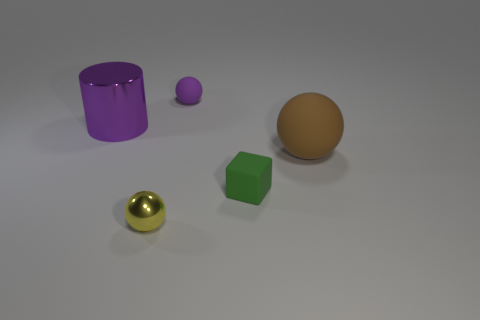Add 3 big red spheres. How many objects exist? 8 Subtract all balls. How many objects are left? 2 Add 5 metallic objects. How many metallic objects are left? 7 Add 1 brown cylinders. How many brown cylinders exist? 1 Subtract 0 cyan cubes. How many objects are left? 5 Subtract all large purple cylinders. Subtract all small objects. How many objects are left? 1 